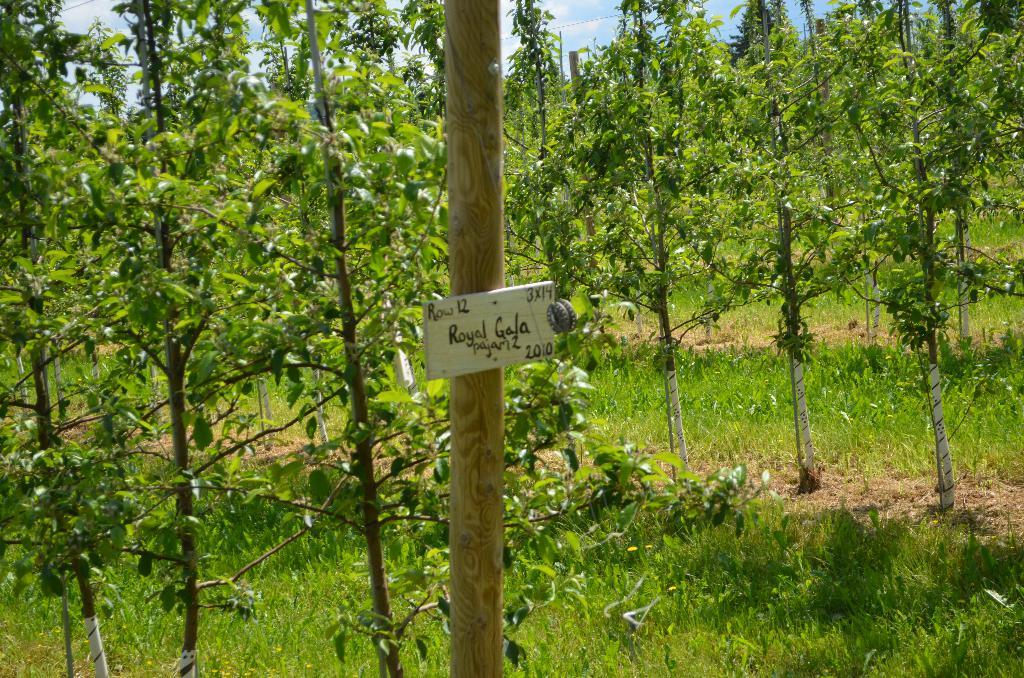What is located in the foreground of the image? There is a board attached to a pole in the foreground of the image. What can be seen in the background of the image? There are trees, grass, and the sky visible in the background of the image. What is the condition of the sky in the image? The sky is visible in the background of the image, and there are clouds present. What type of apparatus is being used to fulfill the desire of the person in the image? There is no person present in the image, and no apparatus can be seen being used to fulfill a desire. 